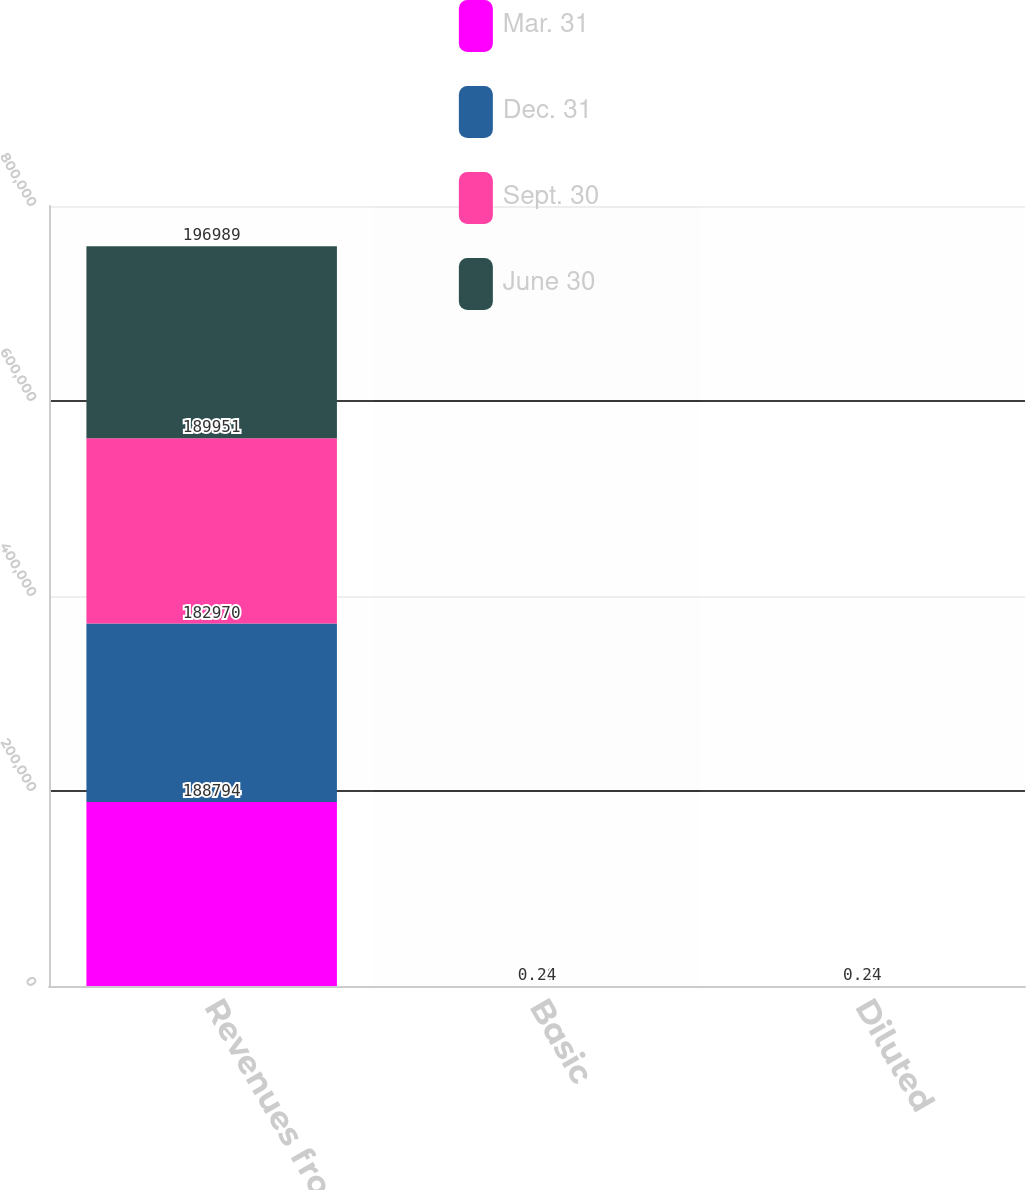Convert chart. <chart><loc_0><loc_0><loc_500><loc_500><stacked_bar_chart><ecel><fcel>Revenues from rental<fcel>Basic<fcel>Diluted<nl><fcel>Mar. 31<fcel>188794<fcel>0.34<fcel>0.34<nl><fcel>Dec. 31<fcel>182970<fcel>0.33<fcel>0.32<nl><fcel>Sept. 30<fcel>189951<fcel>0.38<fcel>0.37<nl><fcel>June 30<fcel>196989<fcel>0.24<fcel>0.24<nl></chart> 